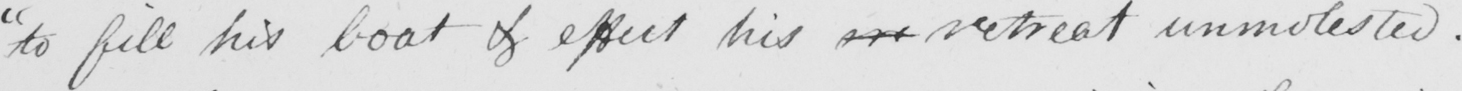Transcribe the text shown in this historical manuscript line. " to fill his boat & effect his   <gap/>   retreat unmolested . 